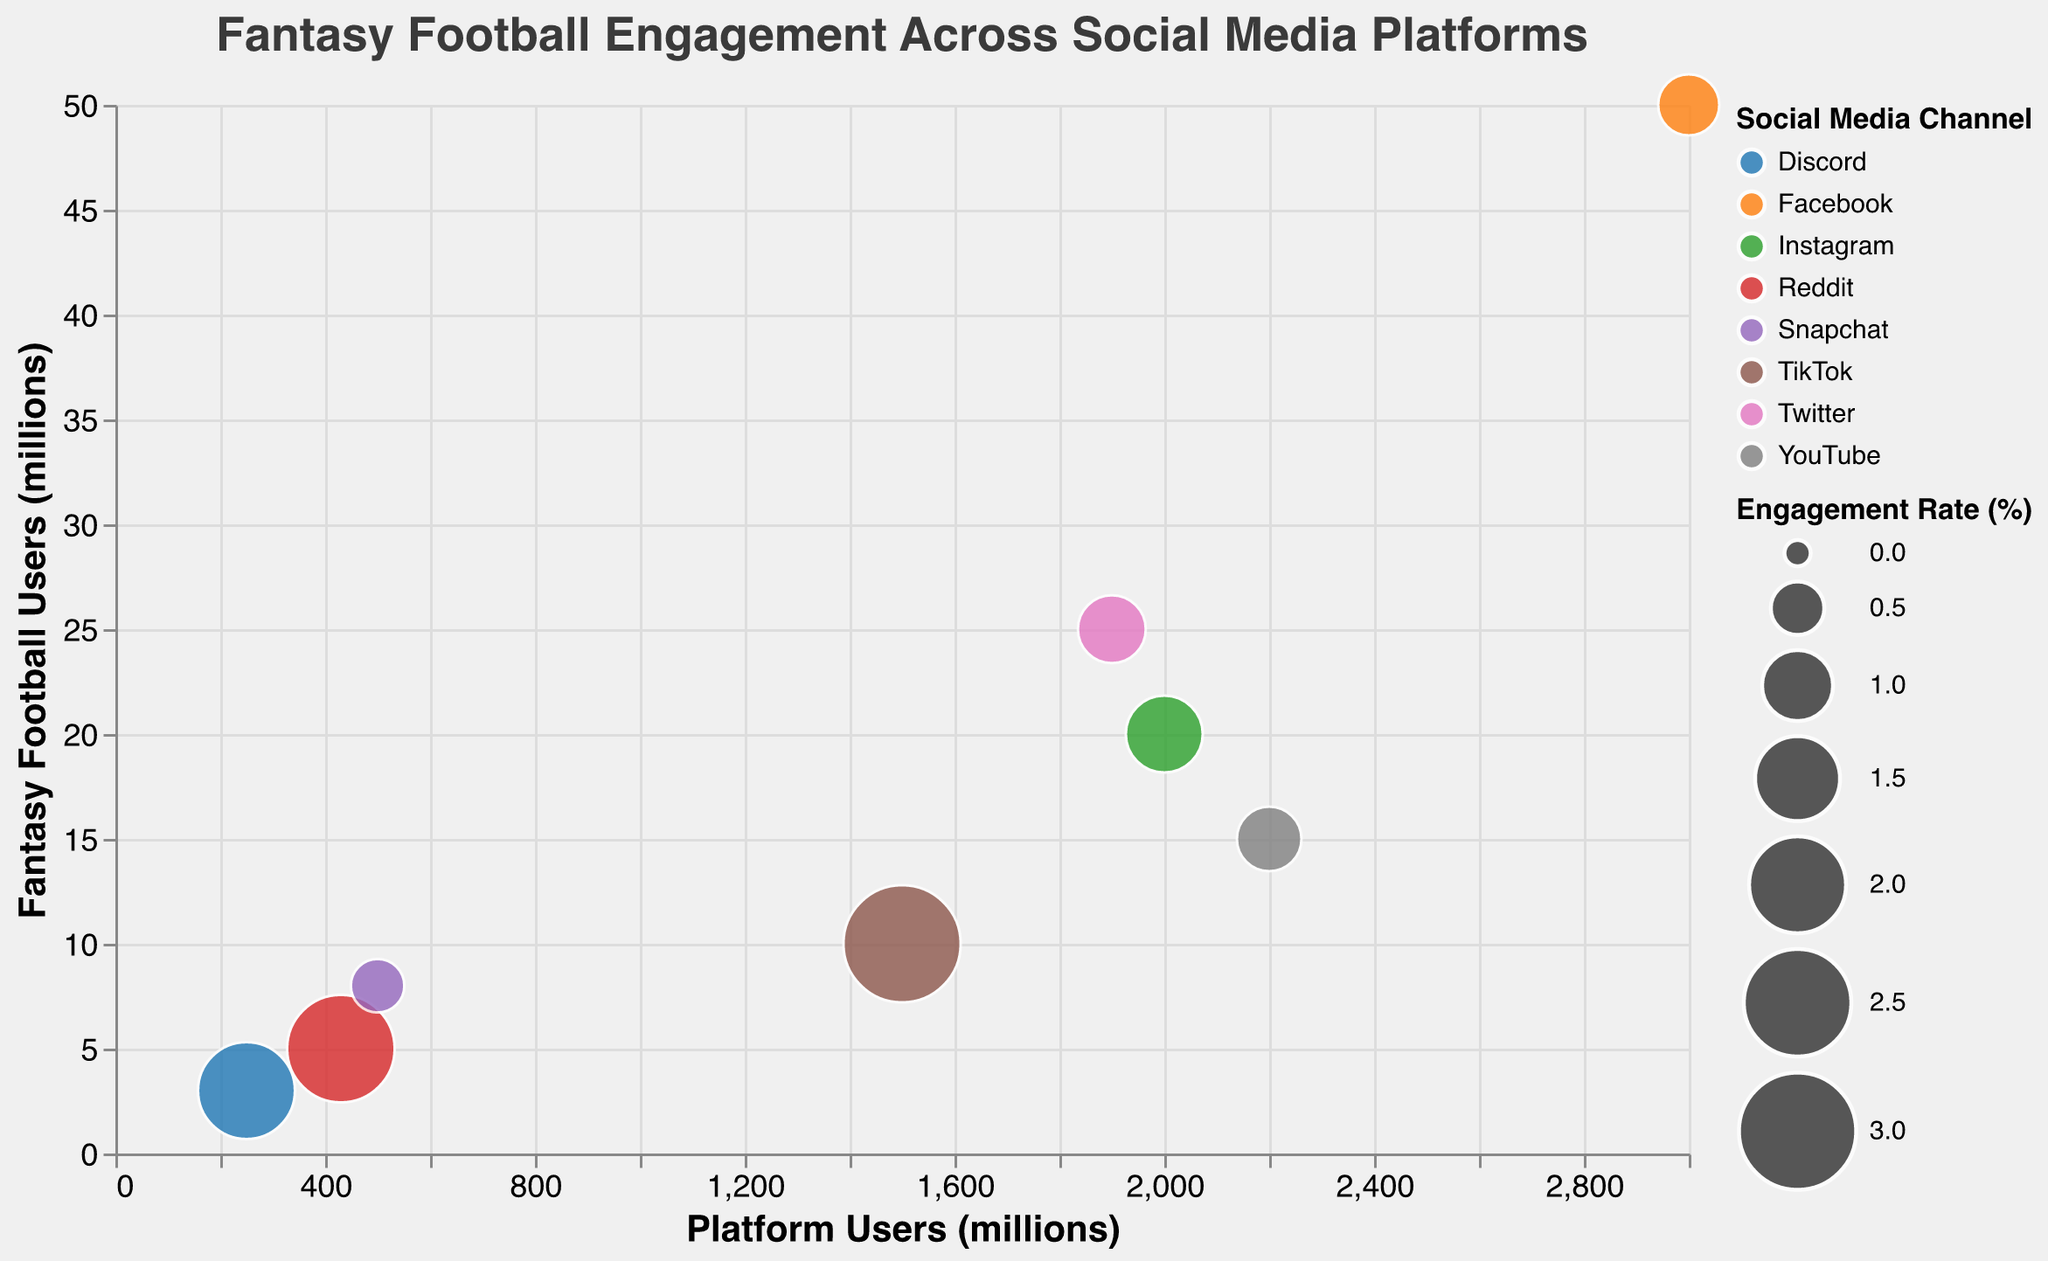What is the title of the chart? The title is located at the top center of the chart. It is stylized to be in Helvetica font, 18 points in size.
Answer: Fantasy Football Engagement Across Social Media Platforms How many data points are represented in the chart? There are eight different channels represented in the dataset and each has a corresponding data point on the chart, as indicated by the Channel legend and data marks.
Answer: Eight Which social media platform has the highest engagement rate for fantasy football users? By looking at the size of the bubbles and the tooltip information, we can see that TikTok has the largest bubble, indicating the highest engagement rate.
Answer: TikTok What is the engagement rate on Reddit? Hovering over the bubble for Reddit or checking the legend and tooltip gives us the engagement rate percentage specific for Reddit.
Answer: 2.5% Which platform has the smallest number of fantasy football users among the ones shown in the chart? By examining the vertical axis (Fantasy Football Users) and comparing the heights of the bubbles, Discord has the smallest number of fantasy football users.
Answer: Discord Compare the fantasy football user base between Instagram and YouTube. By referring to the vertical positions of the bubbles, Instagram has 20 million fantasy football users while YouTube has 15 million. This is indicated by the y-axis positions of the corresponding bubbles.
Answer: Instagram has more Calculate the total number of platform users for Twitter, TikTok, and Reddit combined. By summing the platform users from Twitter (1900 million), TikTok (1500 million), and Reddit (430 million), the total number is 3830 million.
Answer: 3830 million Among the platforms with more than 2000 million users, which one has the highest engagement rate? Filtering the platforms that meet the criteria: Facebook (3000 million, 0.7%), Instagram (2000 million, 1.2%), and YouTube (2200 million, 0.8%). Instagram has the highest engagement rate among these.
Answer: Instagram What is the combined fantasy football user base for Facebook and Twitter? Adding the fantasy football users on Facebook (50 million) and Twitter (25 million) results in a total of 75 million users.
Answer: 75 million users Do TikTok and Reddit have a higher or lower engagement rate than Facebook and Snapchat? TikTok (3.0%) and Reddit (2.5%) have a significantly higher engagement rate compared to Facebook (0.7%) and Snapchat (0.5%), as seen by the relative sizes of the bubbles.
Answer: Higher 